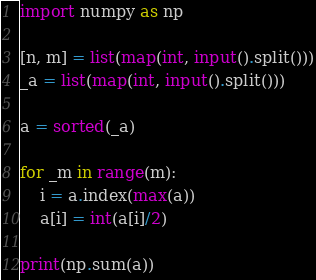Convert code to text. <code><loc_0><loc_0><loc_500><loc_500><_Python_>import numpy as np

[n, m] = list(map(int, input().split()))
_a = list(map(int, input().split()))

a = sorted(_a)

for _m in range(m):
    i = a.index(max(a))
    a[i] = int(a[i]/2)

print(np.sum(a))</code> 